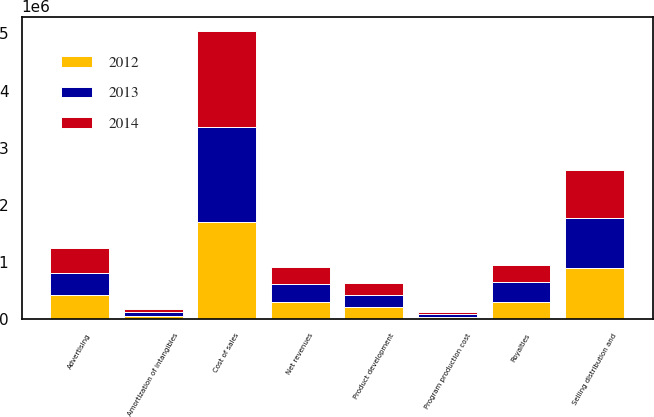Convert chart. <chart><loc_0><loc_0><loc_500><loc_500><stacked_bar_chart><ecel><fcel>Net revenues<fcel>Cost of sales<fcel>Royalties<fcel>Product development<fcel>Advertising<fcel>Amortization of intangibles<fcel>Program production cost<fcel>Selling distribution and<nl><fcel>2012<fcel>305317<fcel>1.69837e+06<fcel>305317<fcel>222556<fcel>420256<fcel>52708<fcel>47086<fcel>895537<nl><fcel>2013<fcel>305317<fcel>1.6729e+06<fcel>338919<fcel>207591<fcel>398098<fcel>78186<fcel>47690<fcel>871679<nl><fcel>2014<fcel>305317<fcel>1.67198e+06<fcel>302066<fcel>201197<fcel>422239<fcel>50569<fcel>41800<fcel>847347<nl></chart> 